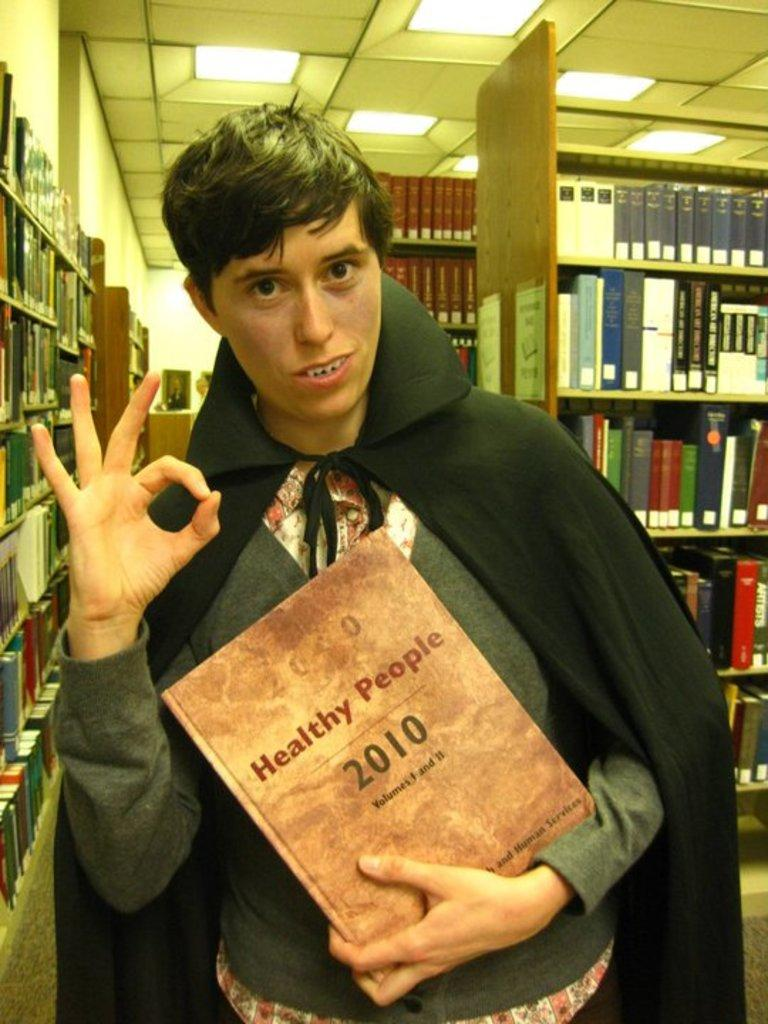Provide a one-sentence caption for the provided image. A young man dressed as a vampire holding a book named, "Healthy People 2010". 